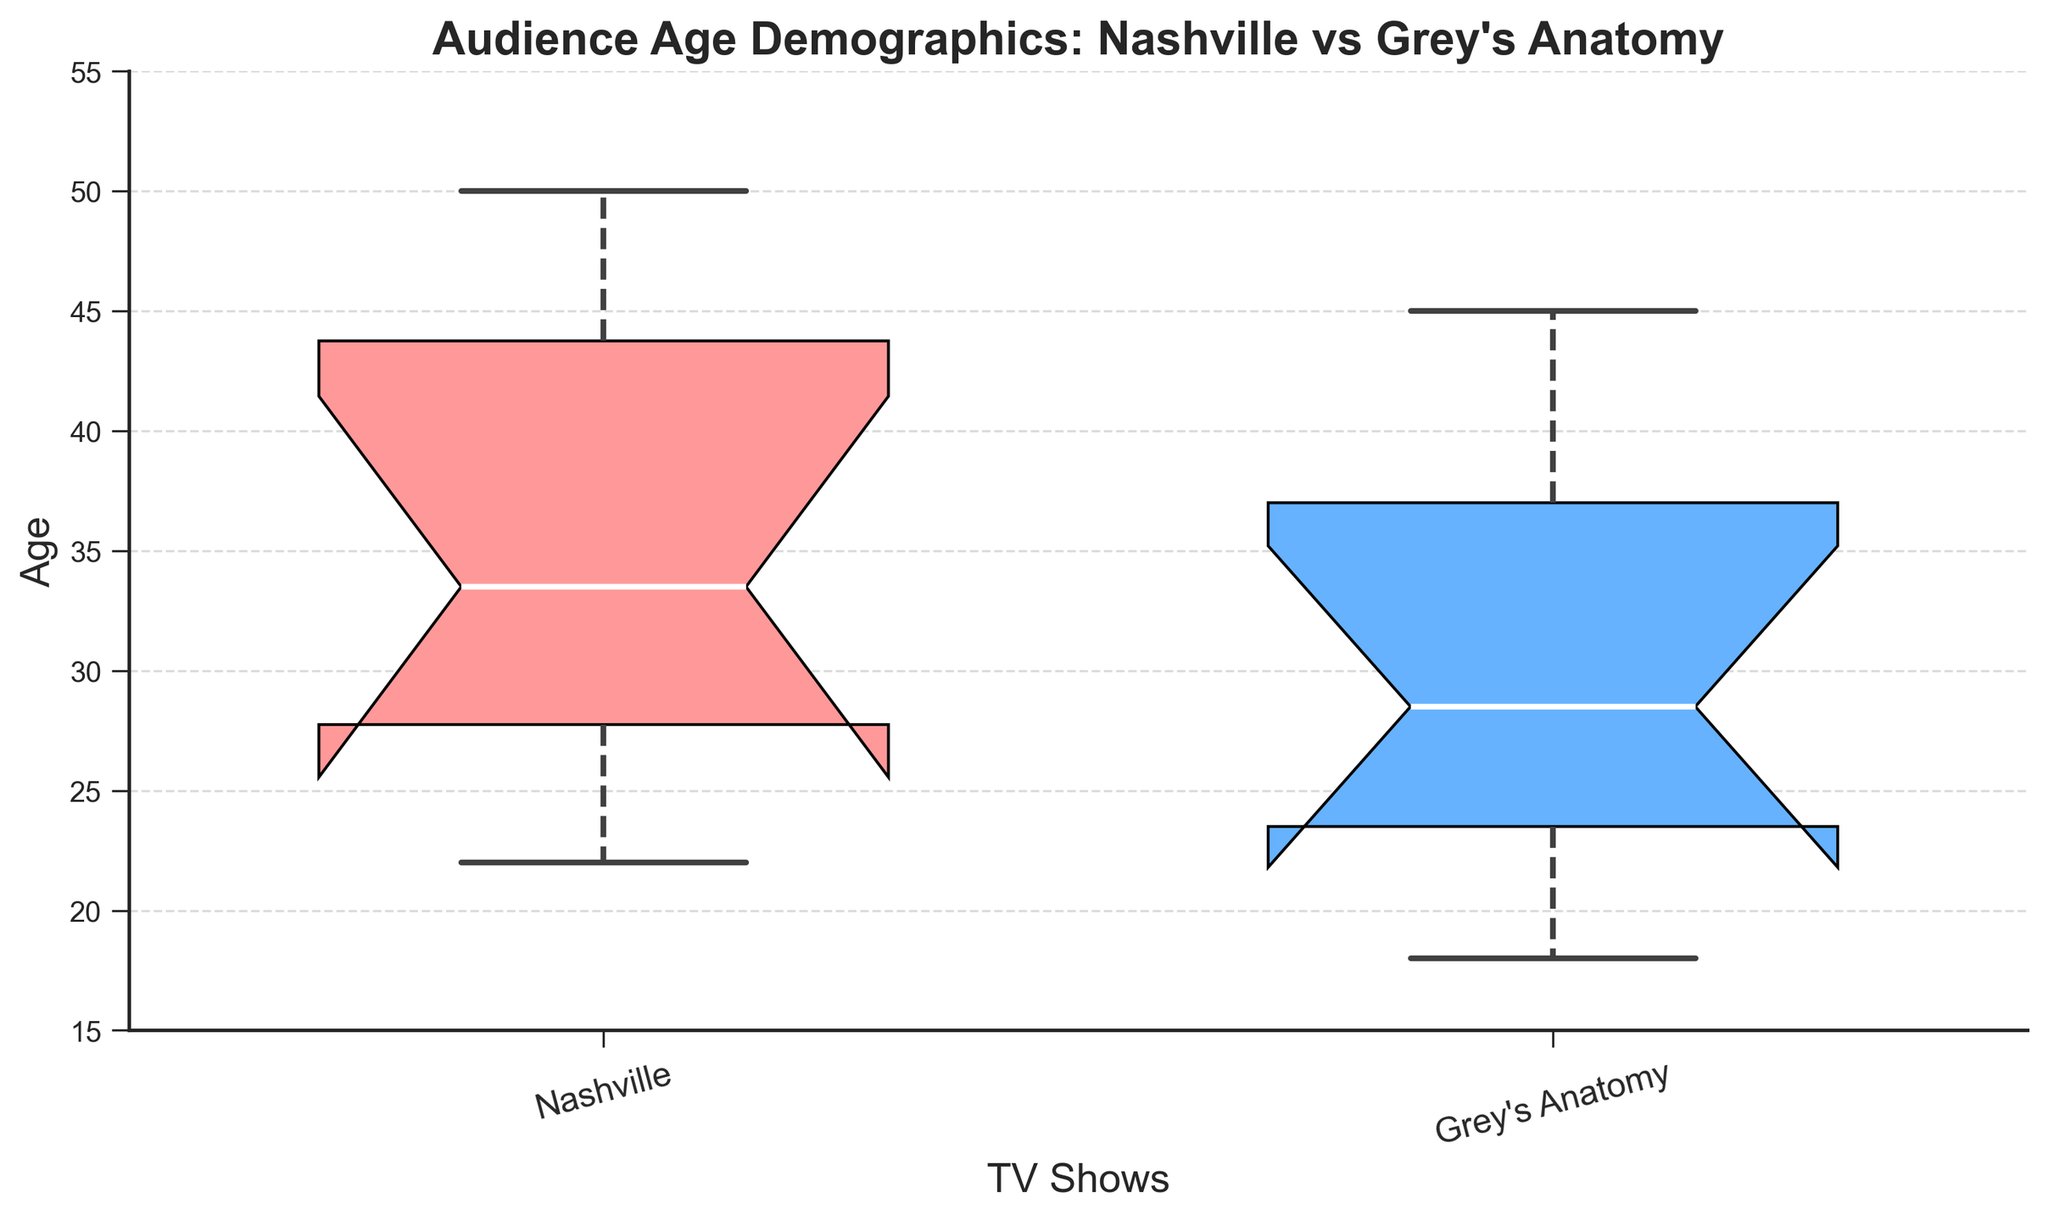What is the title of the figure? The title is located at the top of the figure and it provides a brief description of the data being visualized.
Answer: Audience Age Demographics: Nashville vs Grey's Anatomy What do the x-axis labels represent? The x-axis labels indicate the TV shows that are being compared in the plot.
Answer: TV Shows What are the lower and upper age limits represented on the y-axis? The y-axis starts at the bottom-most value and ends at the top-most value, representing the range of ages.
Answer: 15 to 55 What colors are used for the box plots of Nashville and Grey's Anatomy? The colors fill the boxes representing each show and visually differentiate the two groups.
Answer: Nashville is pink, Grey's Anatomy is blue What is the median age for Nashville's audience? The median is represented by the line inside the box plot for Nashville.
Answer: 35 What is the difference between the median ages of Nashville's and Grey's Anatomy's audiences? Find the median for both shows and subtract the smaller from the larger. The median for Nashville is 35 and for Grey's Anatomy is 27. The difference is 35 - 27.
Answer: 8 Which show has a wider age range of its audience? The age range is the difference between the maximum and minimum values represented by the whiskers of each box plot. Compare the ranges of both shows.
Answer: Nashville What is the interquartile range (IQR) for Grey's Anatomy's audience age? The IQR is the range between the first quartile (bottom of the box) and the third quartile (top of the box). For Grey's Anatomy, the IQR spans from about 22 to 34.
Answer: 12 Which show has the younger audience on average? By comparing the median values for both shows, the one with the smaller median age has the younger audience on average.
Answer: Grey's Anatomy Are there any outliers in the Nashville audience age data? Outliers are represented by points outside the whiskers of the box plot.
Answer: No 